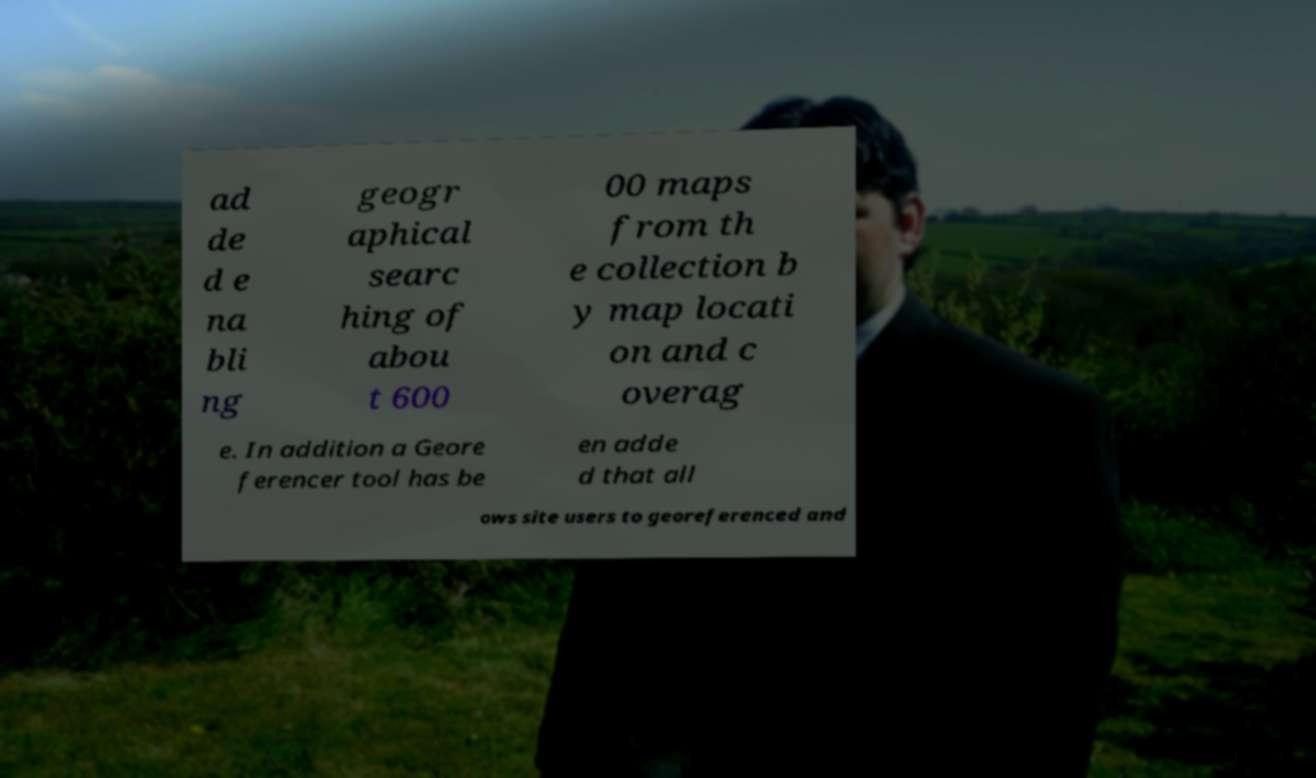There's text embedded in this image that I need extracted. Can you transcribe it verbatim? ad de d e na bli ng geogr aphical searc hing of abou t 600 00 maps from th e collection b y map locati on and c overag e. In addition a Geore ferencer tool has be en adde d that all ows site users to georeferenced and 